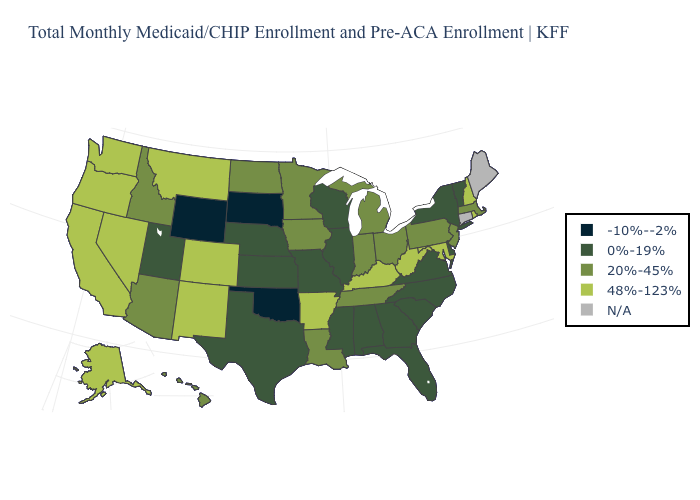What is the value of New Mexico?
Answer briefly. 48%-123%. How many symbols are there in the legend?
Be succinct. 5. Among the states that border Connecticut , does Rhode Island have the highest value?
Keep it brief. Yes. Does Wyoming have the highest value in the USA?
Answer briefly. No. Does the map have missing data?
Write a very short answer. Yes. Does New York have the lowest value in the Northeast?
Quick response, please. Yes. Which states have the lowest value in the Northeast?
Answer briefly. New York, Vermont. How many symbols are there in the legend?
Answer briefly. 5. Name the states that have a value in the range 20%-45%?
Keep it brief. Arizona, Hawaii, Idaho, Indiana, Iowa, Louisiana, Massachusetts, Michigan, Minnesota, New Jersey, North Dakota, Ohio, Pennsylvania, Tennessee. What is the value of Missouri?
Be succinct. 0%-19%. What is the value of Utah?
Answer briefly. 0%-19%. Name the states that have a value in the range N/A?
Give a very brief answer. Connecticut, Maine. Which states have the lowest value in the USA?
Write a very short answer. Oklahoma, South Dakota, Wyoming. 